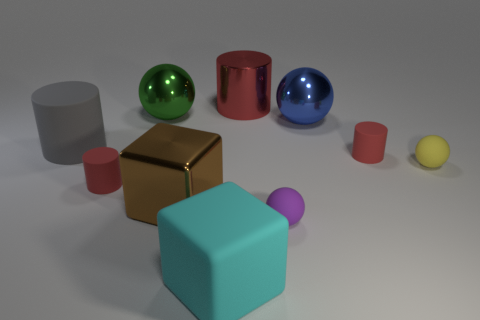There is a blue shiny sphere; is its size the same as the metallic object that is in front of the gray cylinder?
Keep it short and to the point. Yes. How many objects are either small yellow matte objects or purple matte things?
Your answer should be compact. 2. What number of other objects are the same size as the yellow thing?
Offer a very short reply. 3. Is the color of the shiny cube the same as the matte cylinder that is in front of the yellow object?
Provide a short and direct response. No. What number of cubes are yellow objects or red shiny objects?
Offer a terse response. 0. Is there anything else of the same color as the large matte cylinder?
Your answer should be very brief. No. What is the material of the tiny red thing that is right of the red cylinder behind the gray rubber cylinder?
Your answer should be compact. Rubber. Do the gray cylinder and the big cylinder that is right of the large cyan rubber block have the same material?
Keep it short and to the point. No. What number of objects are small matte spheres behind the purple matte thing or blue shiny things?
Offer a very short reply. 2. Are there any shiny spheres that have the same color as the big metal cylinder?
Provide a short and direct response. No. 